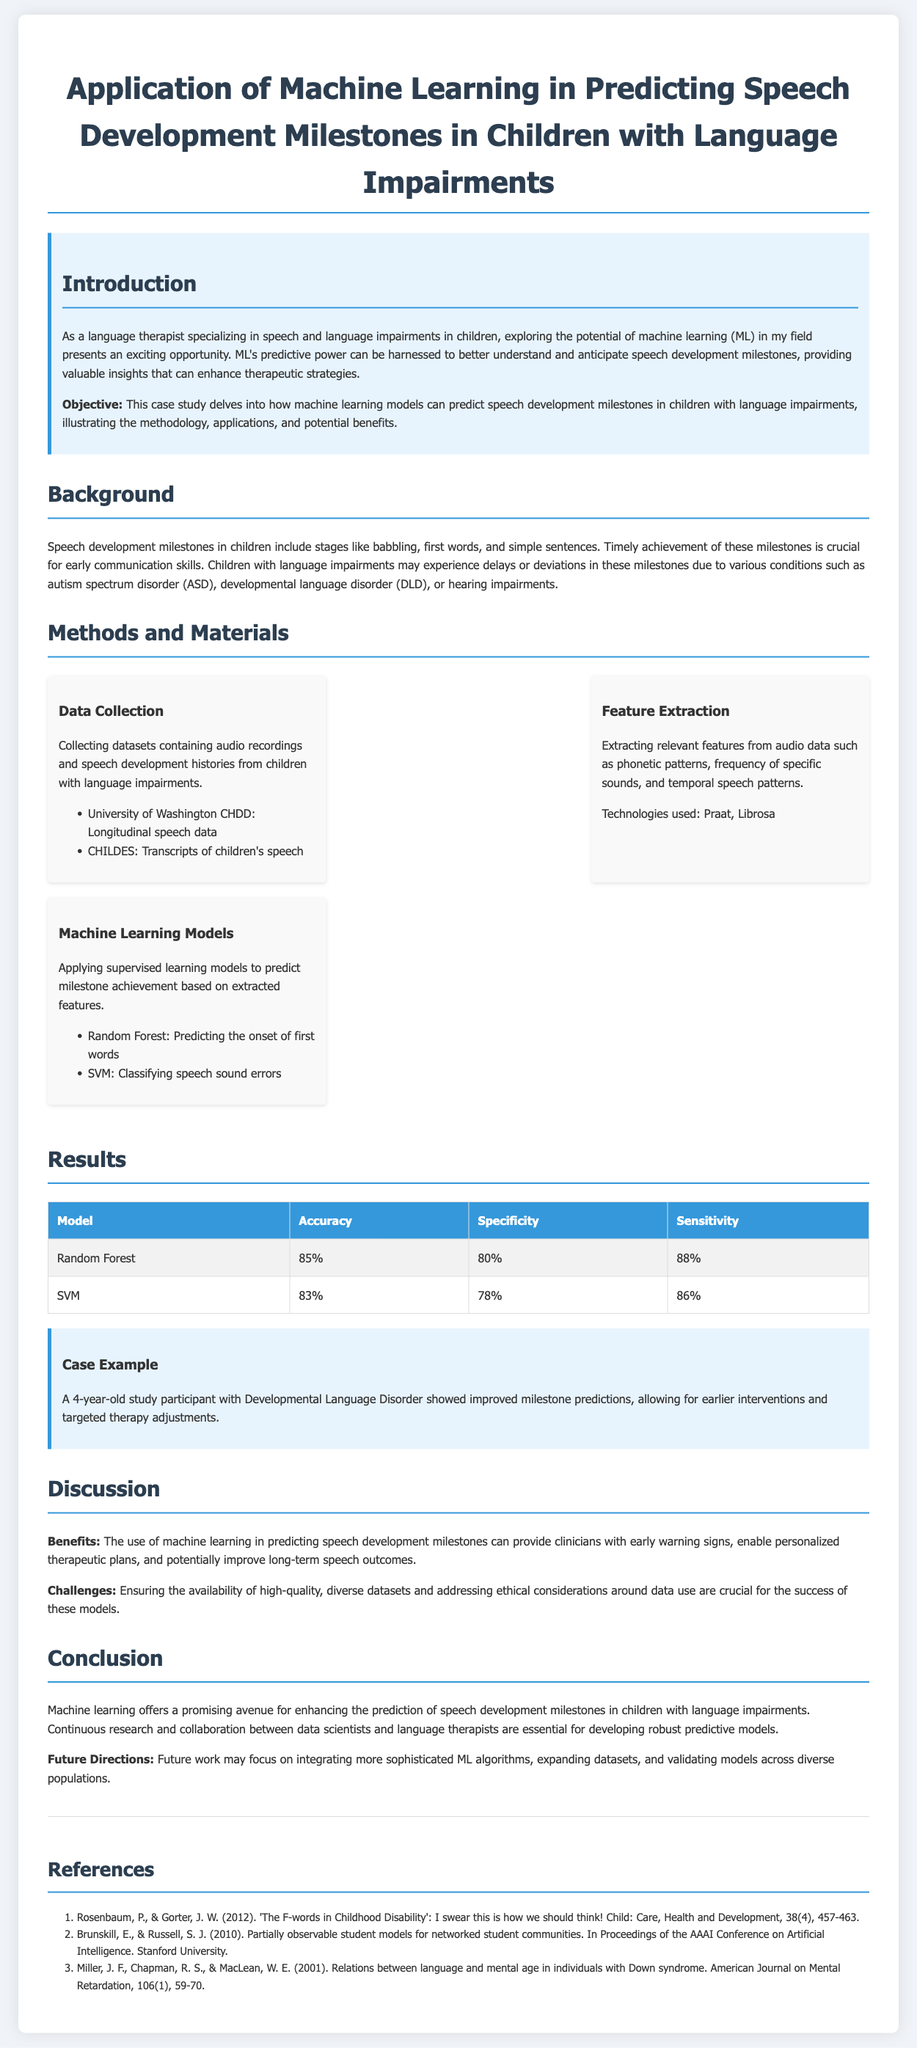What is the objective of this case study? The objective is to explore how machine learning models can predict speech development milestones in children with language impairments.
Answer: To explore how machine learning models can predict speech development milestones in children with language impairments What datasets were used for data collection? Two specific datasets mentioned for data collection are the University of Washington CHDD and CHILDES.
Answer: University of Washington CHDD and CHILDES What machine learning model achieved the highest accuracy? The Random Forest model achieved the highest accuracy at 85%.
Answer: Random Forest What technology was used for feature extraction? The technologies used for feature extraction are Praat and Librosa.
Answer: Praat, Librosa What age was the study participant in the case example? The age of the study participant was four years old.
Answer: 4 years old What is one benefit of using machine learning in this context? One benefit mentioned is enabling personalized therapeutic plans.
Answer: Enabling personalized therapeutic plans What are the two main challenges discussed? The two main challenges include ensuring availability of high-quality datasets and addressing ethical considerations.
Answer: Availability of high-quality datasets, ethical considerations What is the conclusion of the case study? The conclusion states that machine learning offers a promising avenue for enhancing prediction of speech development milestones.
Answer: Machine learning offers a promising avenue for enhancing prediction of speech development milestones 